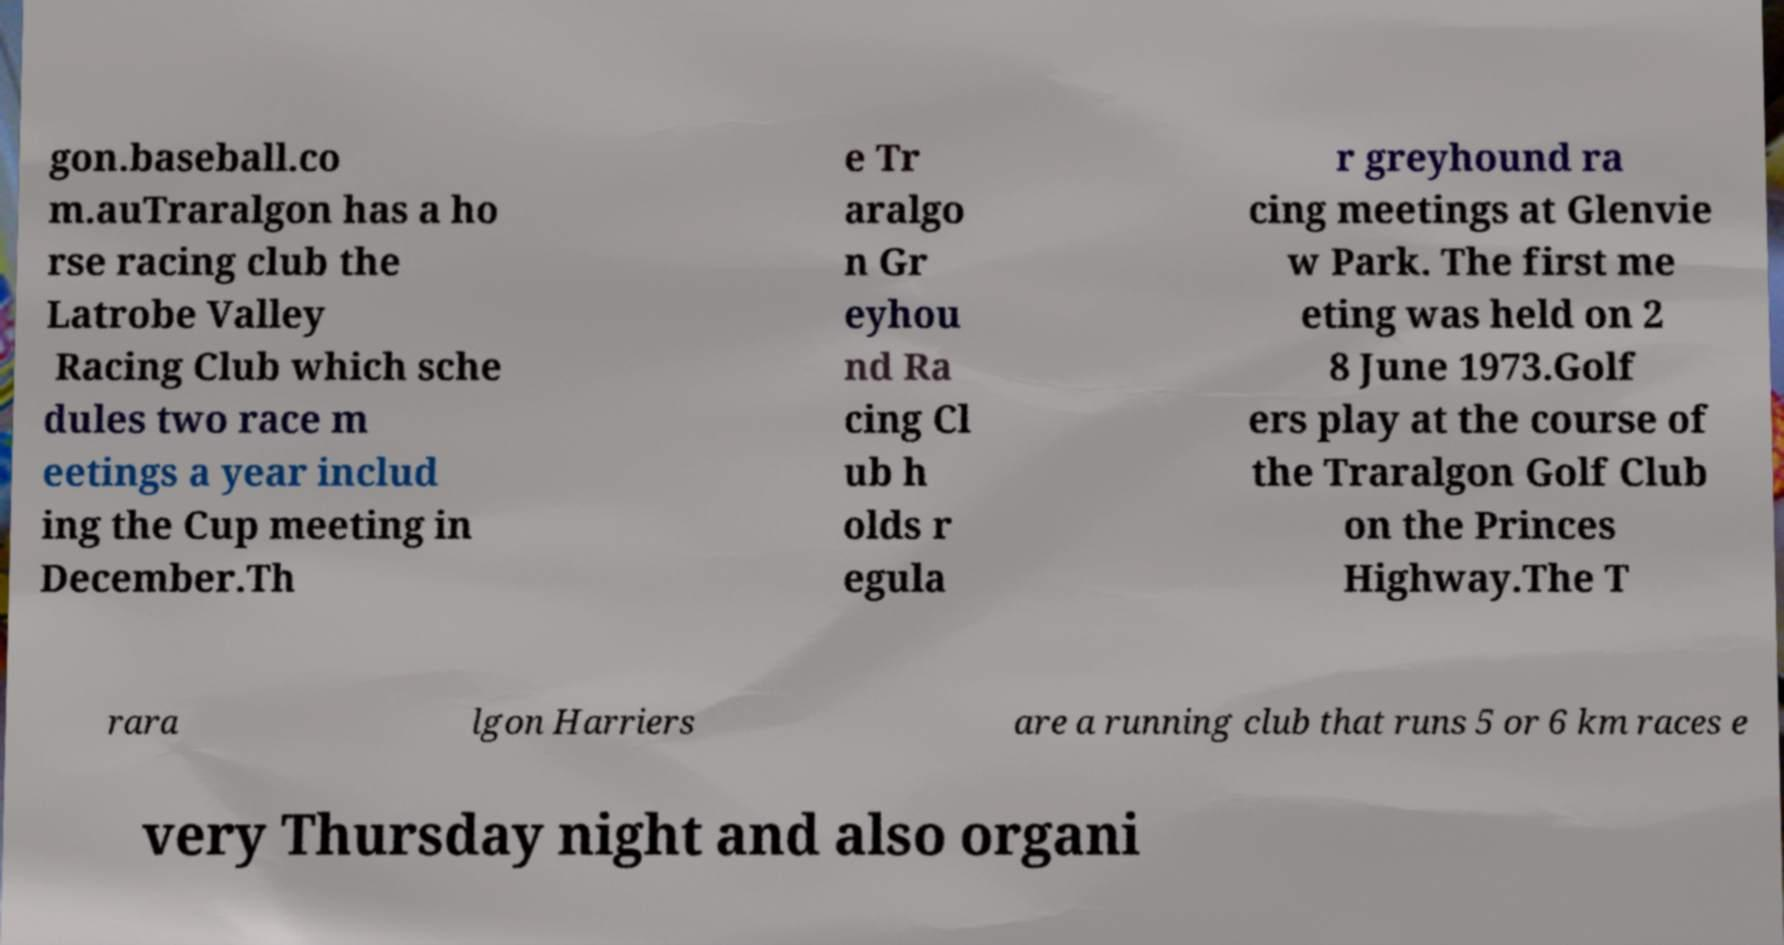Please identify and transcribe the text found in this image. gon.baseball.co m.auTraralgon has a ho rse racing club the Latrobe Valley Racing Club which sche dules two race m eetings a year includ ing the Cup meeting in December.Th e Tr aralgo n Gr eyhou nd Ra cing Cl ub h olds r egula r greyhound ra cing meetings at Glenvie w Park. The first me eting was held on 2 8 June 1973.Golf ers play at the course of the Traralgon Golf Club on the Princes Highway.The T rara lgon Harriers are a running club that runs 5 or 6 km races e very Thursday night and also organi 